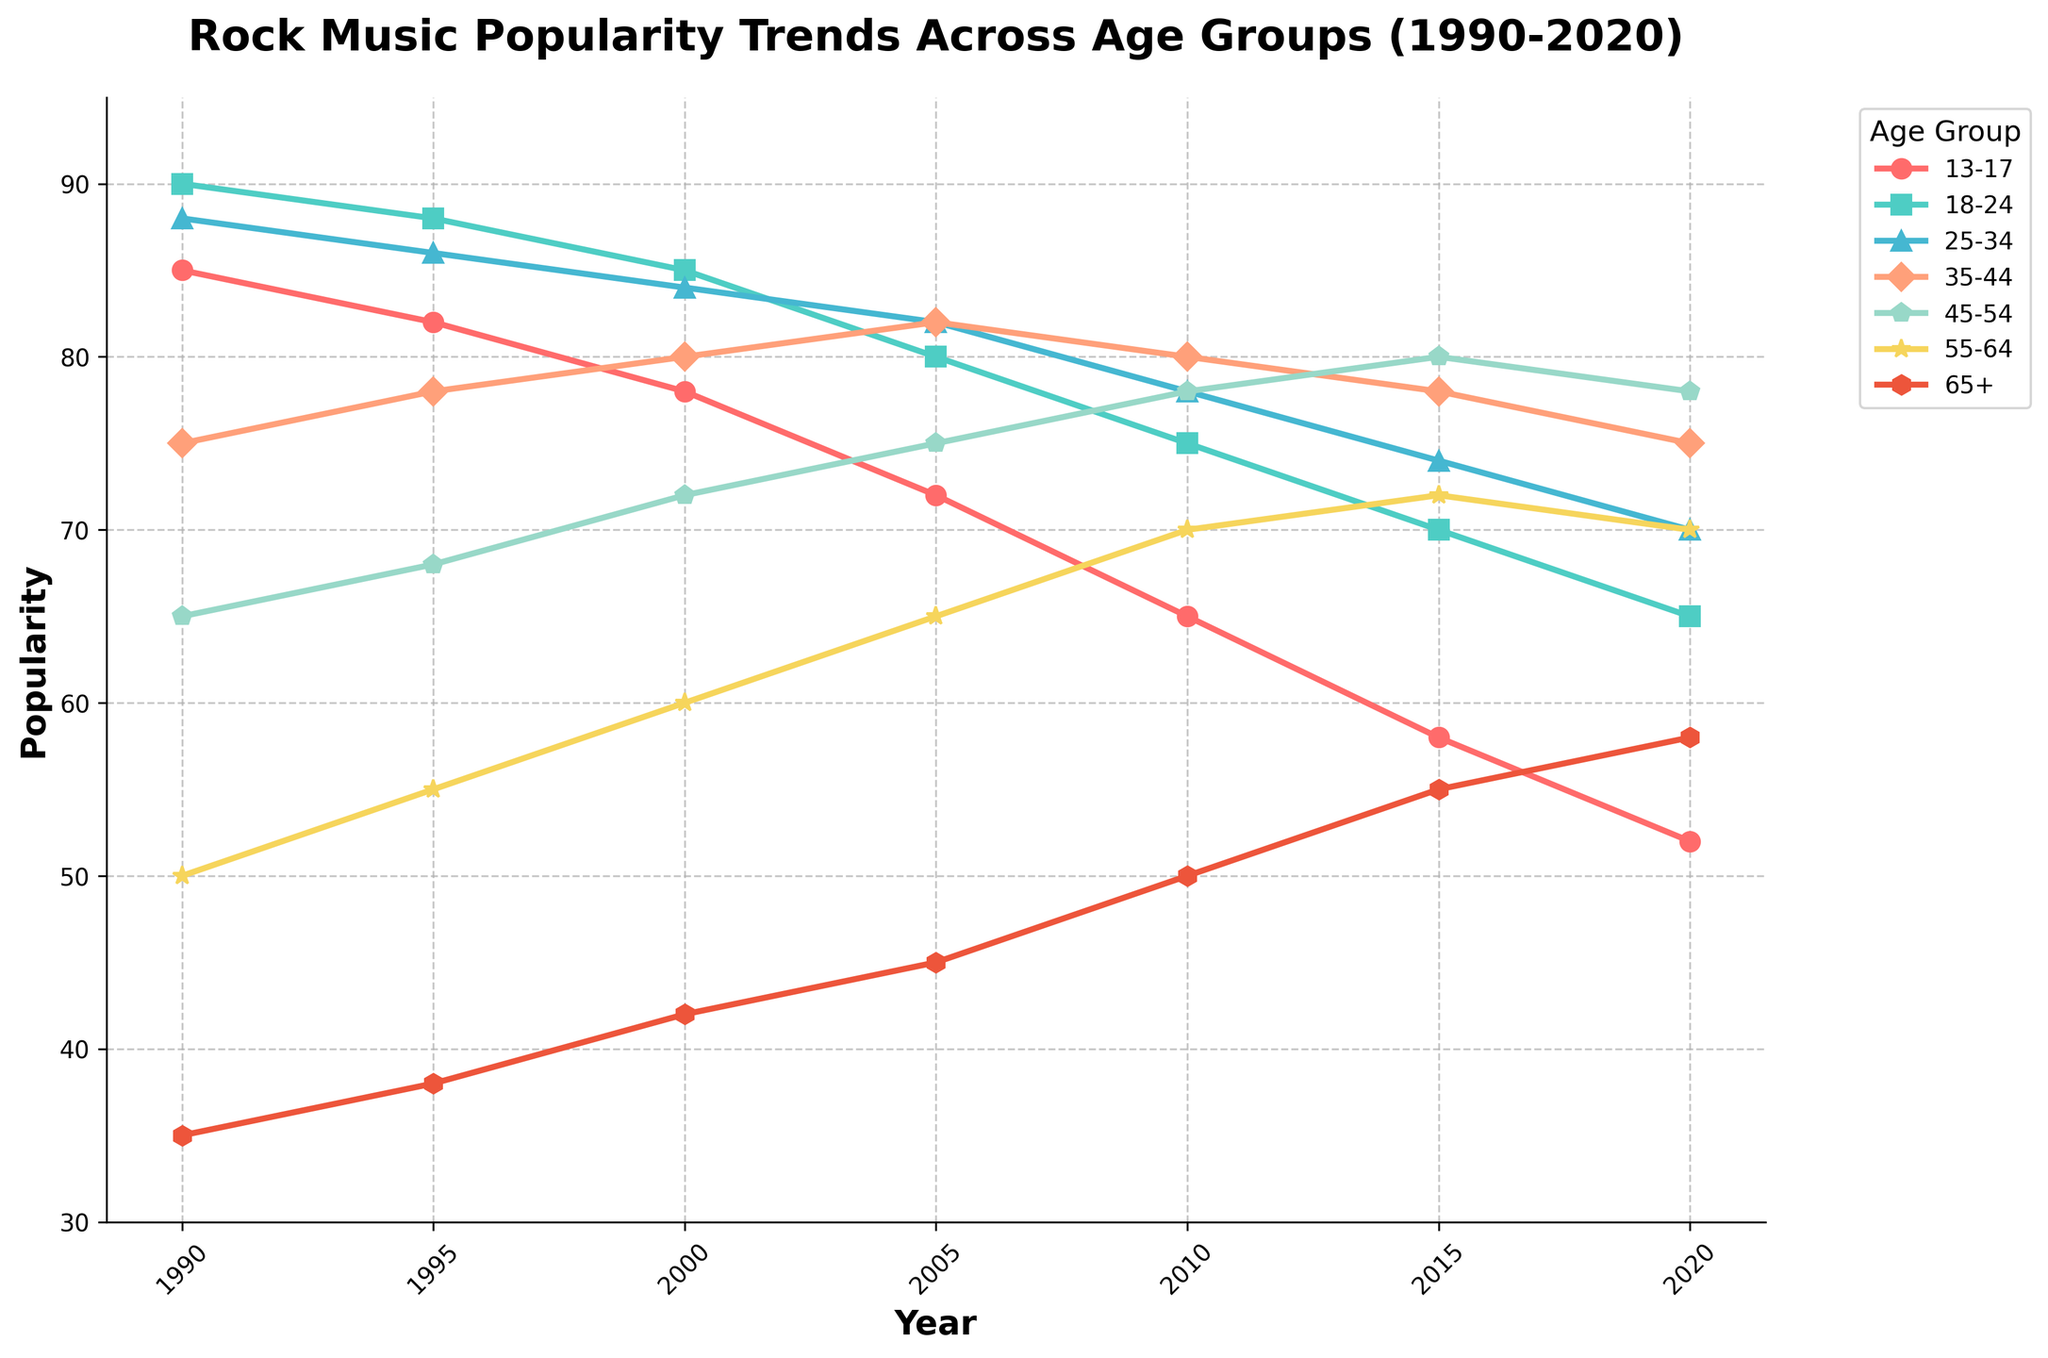What is the trend in rock music popularity for the 13-17 age group from 1990 to 2020? To determine the trend, observe the line representing the 13-17 age group. It starts at 85 in 1990 and gradually declines to 52 by 2020. This shows a consistent decrease over the 30-year period.
Answer: A consistent decrease Which age group had the highest rock music popularity in 2000? In 2000, look at the data points for each age group. The 18-24 age group had the highest popularity at 85, followed by the 25-34 age group at 84.
Answer: 18-24 age group How did rock music popularity change for the 25-34 age group between 1995 and 2015? In 1995, the popularity for the 25-34 age group was 86. By 2015, it decreased to 74. Calculate the difference: 86 - 74 = 12, indicating a drop in popularity by 12 points.
Answer: Decreased by 12 points Between which years did the 45-54 age group see the most significant increase in rock music popularity? Look at the popularity points for the 45-54 age group across the years. The biggest jump is between 2000 (72) and 2005 (75), showing an increase of 3 points.
Answer: 2000 to 2005 Which two age groups had the closest rock music popularity values in 2010? Compare the popularity values for all age groups in 2010. The 35-44 and 45-54 age groups both have values close to each other, at 80 and 78 respectively, making their values the closest.
Answer: 35-44 and 45-54 age groups What is the average popularity score for the 55-64 age group over the 30-year period? Add the popularity scores for the 55-64 age group from 1990 to 2020: 50 + 55 + 60 + 65 + 70 + 72 + 70 = 442. Divide by 7 (number of data points): 442 / 7 ≈ 63.14.
Answer: Approximately 63.14 How does the popularity trend for the 65+ age group compare before and after 2005? Before 2005, the 65+ age group shows a gradual increase from 35 in 1990 to 45 in 2005. After 2005, the trend continues to rise from 50 in 2010 to 58 in 2020. Both periods show an increasing trend, but the rate is slightly higher after 2005.
Answer: Increasing trend, slightly higher rate after 2005 Which age group had a decreasing trend in rock music popularity throughout the entire period from 1990 to 2020? Observe all lines to find a consistently decreasing trend. The 13-17 age group line consistently moves downward, indicating a decreasing trend throughout the entire period.
Answer: 13-17 age group By how many points did the rock music popularity for the 18-24 age group decrease between 1990 and 2020? The popularity was 90 in 1990 and decreased to 65 in 2020. Calculate the difference: 90 - 65 = 25.
Answer: Decreased by 25 points 